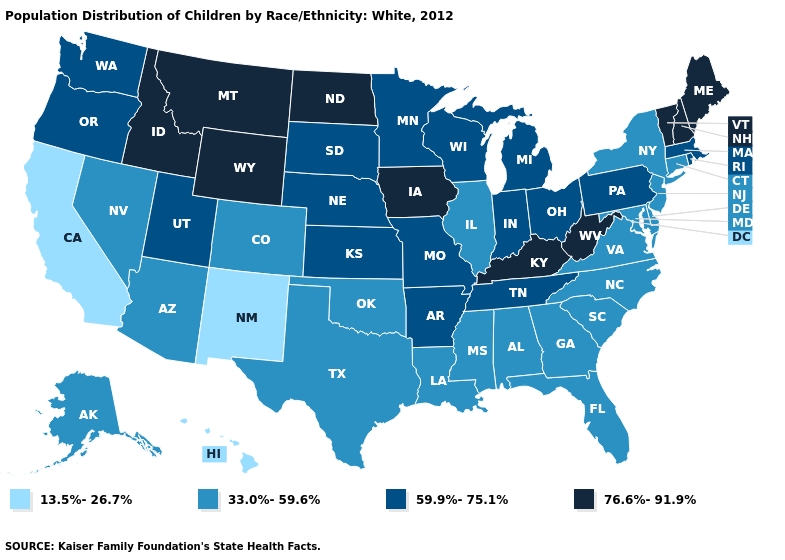Name the states that have a value in the range 59.9%-75.1%?
Keep it brief. Arkansas, Indiana, Kansas, Massachusetts, Michigan, Minnesota, Missouri, Nebraska, Ohio, Oregon, Pennsylvania, Rhode Island, South Dakota, Tennessee, Utah, Washington, Wisconsin. Name the states that have a value in the range 33.0%-59.6%?
Short answer required. Alabama, Alaska, Arizona, Colorado, Connecticut, Delaware, Florida, Georgia, Illinois, Louisiana, Maryland, Mississippi, Nevada, New Jersey, New York, North Carolina, Oklahoma, South Carolina, Texas, Virginia. Name the states that have a value in the range 13.5%-26.7%?
Concise answer only. California, Hawaii, New Mexico. What is the value of Utah?
Short answer required. 59.9%-75.1%. Does the first symbol in the legend represent the smallest category?
Keep it brief. Yes. What is the highest value in the USA?
Concise answer only. 76.6%-91.9%. What is the value of New Jersey?
Keep it brief. 33.0%-59.6%. Among the states that border Montana , does Wyoming have the highest value?
Write a very short answer. Yes. Does Kentucky have the highest value in the South?
Answer briefly. Yes. Name the states that have a value in the range 13.5%-26.7%?
Short answer required. California, Hawaii, New Mexico. What is the highest value in the USA?
Keep it brief. 76.6%-91.9%. Name the states that have a value in the range 76.6%-91.9%?
Write a very short answer. Idaho, Iowa, Kentucky, Maine, Montana, New Hampshire, North Dakota, Vermont, West Virginia, Wyoming. What is the lowest value in states that border Massachusetts?
Quick response, please. 33.0%-59.6%. Name the states that have a value in the range 33.0%-59.6%?
Quick response, please. Alabama, Alaska, Arizona, Colorado, Connecticut, Delaware, Florida, Georgia, Illinois, Louisiana, Maryland, Mississippi, Nevada, New Jersey, New York, North Carolina, Oklahoma, South Carolina, Texas, Virginia. Among the states that border West Virginia , does Pennsylvania have the lowest value?
Keep it brief. No. 